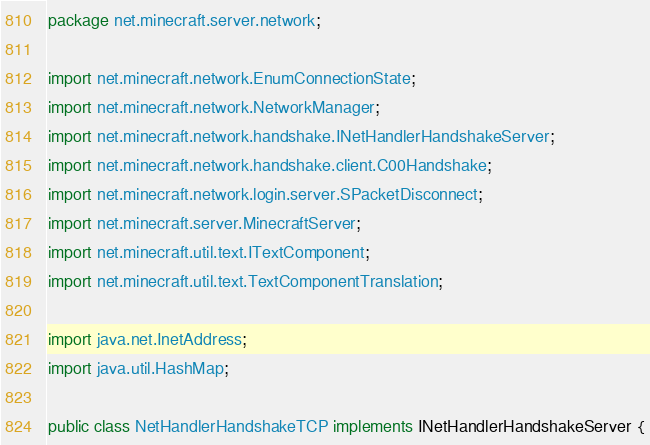Convert code to text. <code><loc_0><loc_0><loc_500><loc_500><_Java_>package net.minecraft.server.network;

import net.minecraft.network.EnumConnectionState;
import net.minecraft.network.NetworkManager;
import net.minecraft.network.handshake.INetHandlerHandshakeServer;
import net.minecraft.network.handshake.client.C00Handshake;
import net.minecraft.network.login.server.SPacketDisconnect;
import net.minecraft.server.MinecraftServer;
import net.minecraft.util.text.ITextComponent;
import net.minecraft.util.text.TextComponentTranslation;

import java.net.InetAddress;
import java.util.HashMap;

public class NetHandlerHandshakeTCP implements INetHandlerHandshakeServer {</code> 